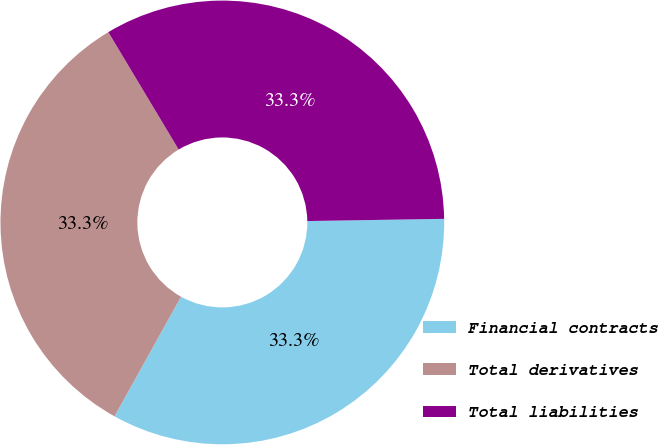Convert chart to OTSL. <chart><loc_0><loc_0><loc_500><loc_500><pie_chart><fcel>Financial contracts<fcel>Total derivatives<fcel>Total liabilities<nl><fcel>33.33%<fcel>33.33%<fcel>33.33%<nl></chart> 